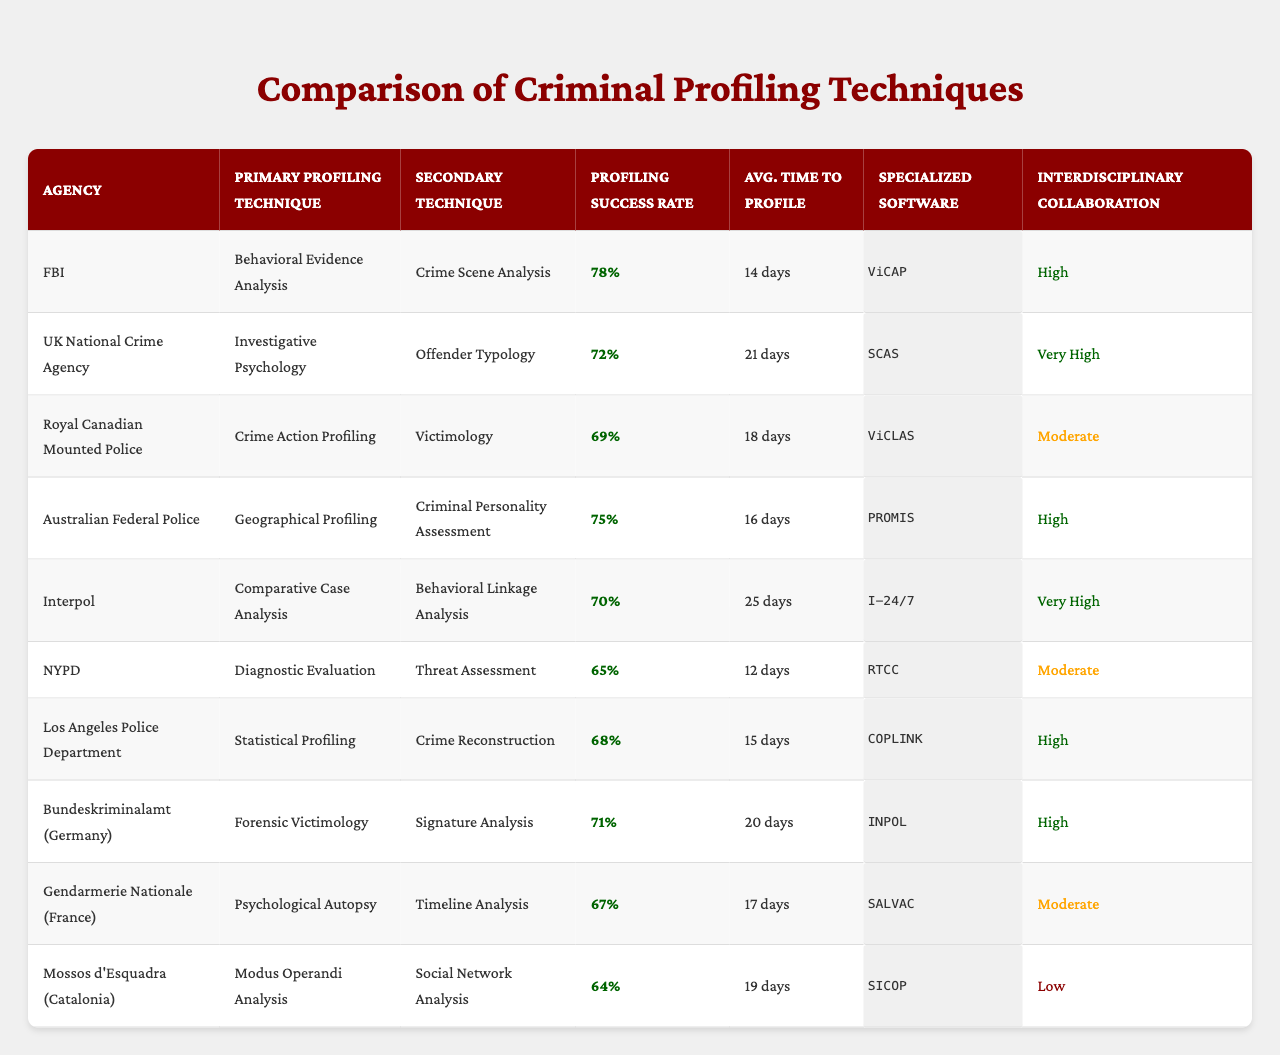What is the primary profiling technique used by the FBI? According to the table, the FBI uses Behavioral Evidence Analysis as its primary profiling technique.
Answer: Behavioral Evidence Analysis Which agency has the lowest profiling success rate? By examining the success rates, the NYPD has the lowest rate at 65%.
Answer: NYPD What is the average time to profile for the Royal Canadian Mounted Police? The table indicates that the Royal Canadian Mounted Police takes 18 days on average to complete a profile.
Answer: 18 days Which agency uses "ViCAP" software? The FBI is the agency that uses "ViCAP" as its specialized software.
Answer: FBI What is the average profiling success rate across all agencies? To compute the average, sum all success rates (78 + 72 + 69 + 75 + 70 + 65 + 68 + 71 + 67 + 64) =  69.5, and then divide by 10 gives us 69.5%.
Answer: 69.5% True or False: The Australian Federal Police has a higher success rate than the United Kingdom National Crime Agency. The Australian Federal Police has a success rate of 75%, while the UK National Crime Agency has a success rate of 72%. Therefore, the statement is true.
Answer: True Which agency has the highest interdisciplinary collaboration level? The FBI and the UK National Crime Agency both have a "Very High" collaboration level, which is the highest in the table.
Answer: FBI and UK National Crime Agency How does the average time to profile for the UK National Crime Agency compare to that of the Los Angeles Police Department? The UK National Crime Agency takes 21 days to profile, while the Los Angeles Police Department takes 15 days; therefore, the UK National Crime Agency takes 6 days longer.
Answer: 6 days longer Which agency employs the "Psychological Autopsy" technique, and what is its profiling success rate? The Gendarmerie Nationale (France) employs the "Psychological Autopsy" technique, and its profiling success rate is 67%.
Answer: Gendarmerie Nationale, 67% Is there any agency with a "Low" level of interdisciplinary collaboration? The only agency with a "Low" collaboration level is the Mossos d'Esquadra.
Answer: Yes, Mossos d'Esquadra What are the primary and secondary techniques used by Interpol? Interpol’s primary technique is Comparative Case Analysis, and its secondary technique is Behavioral Linkage Analysis.
Answer: Comparative Case Analysis and Behavioral Linkage Analysis 